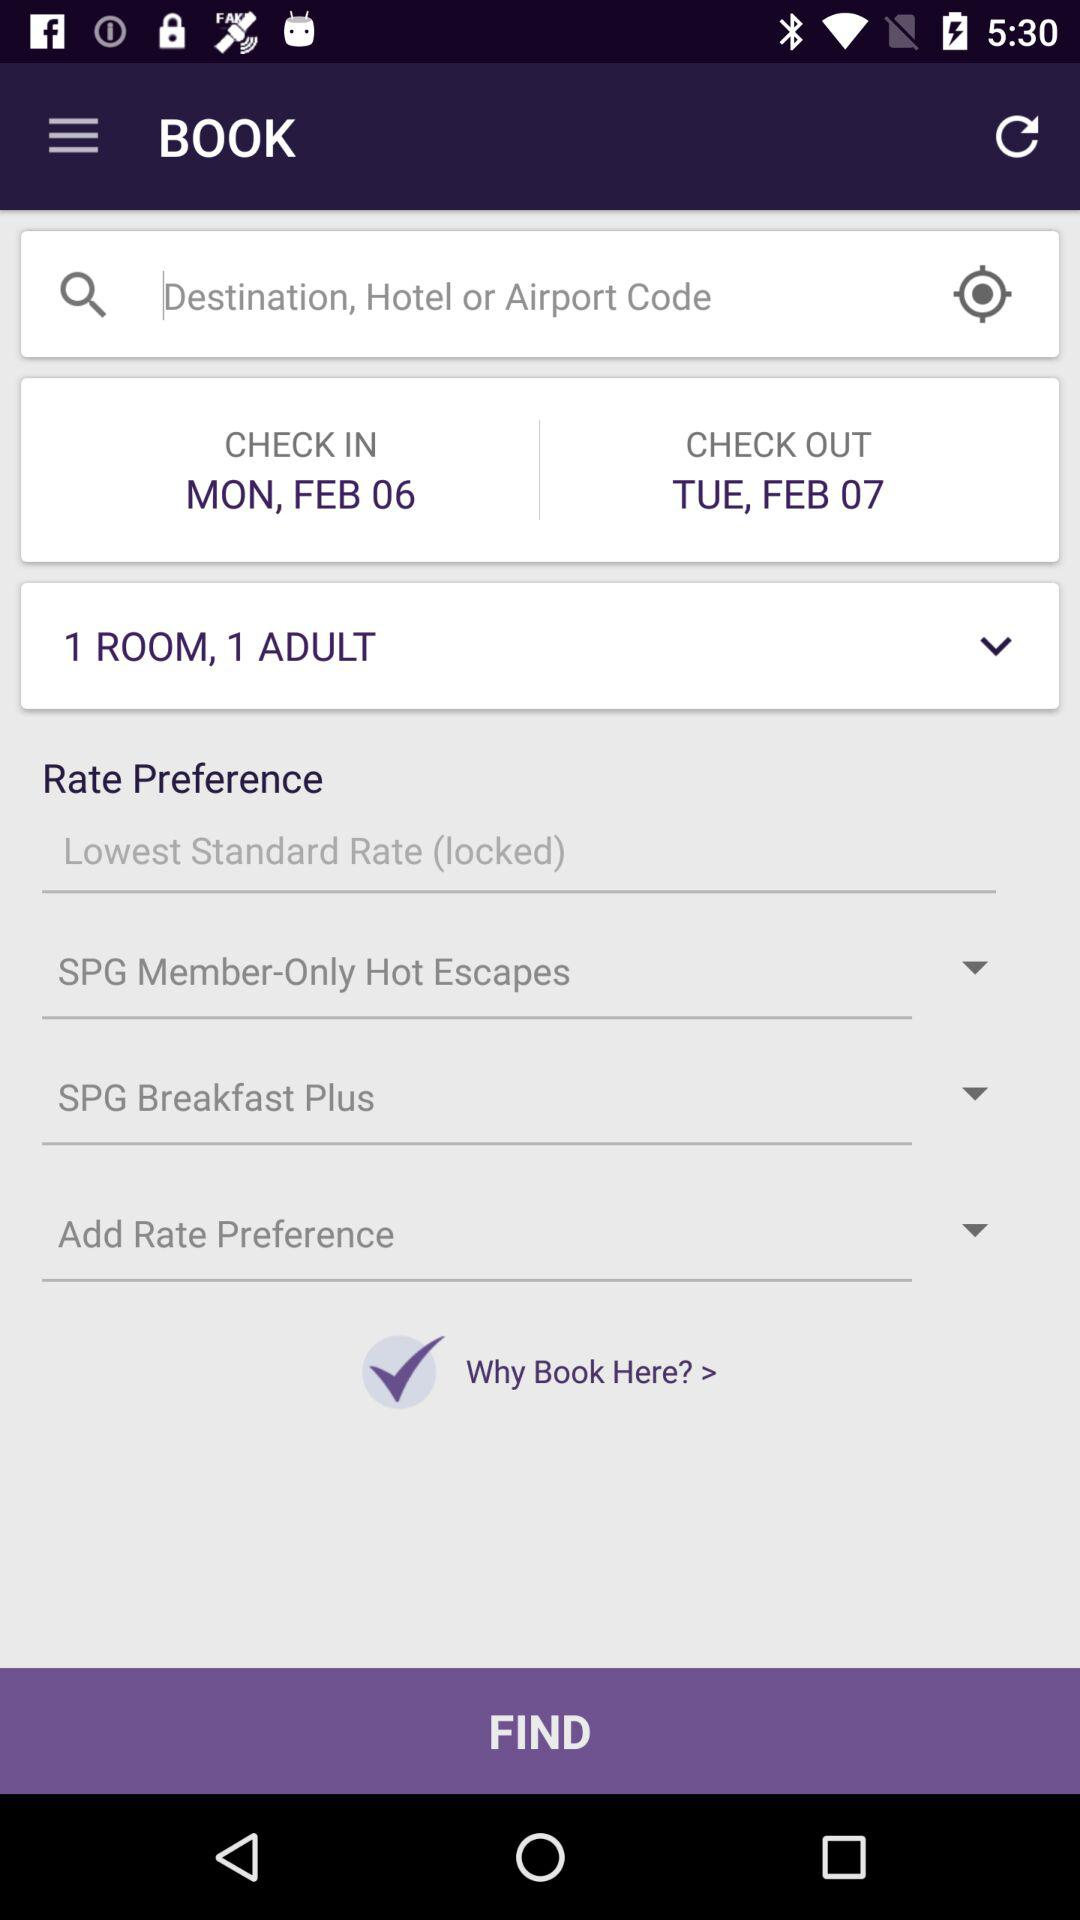What is the number of adults? The number of adults is 1. 